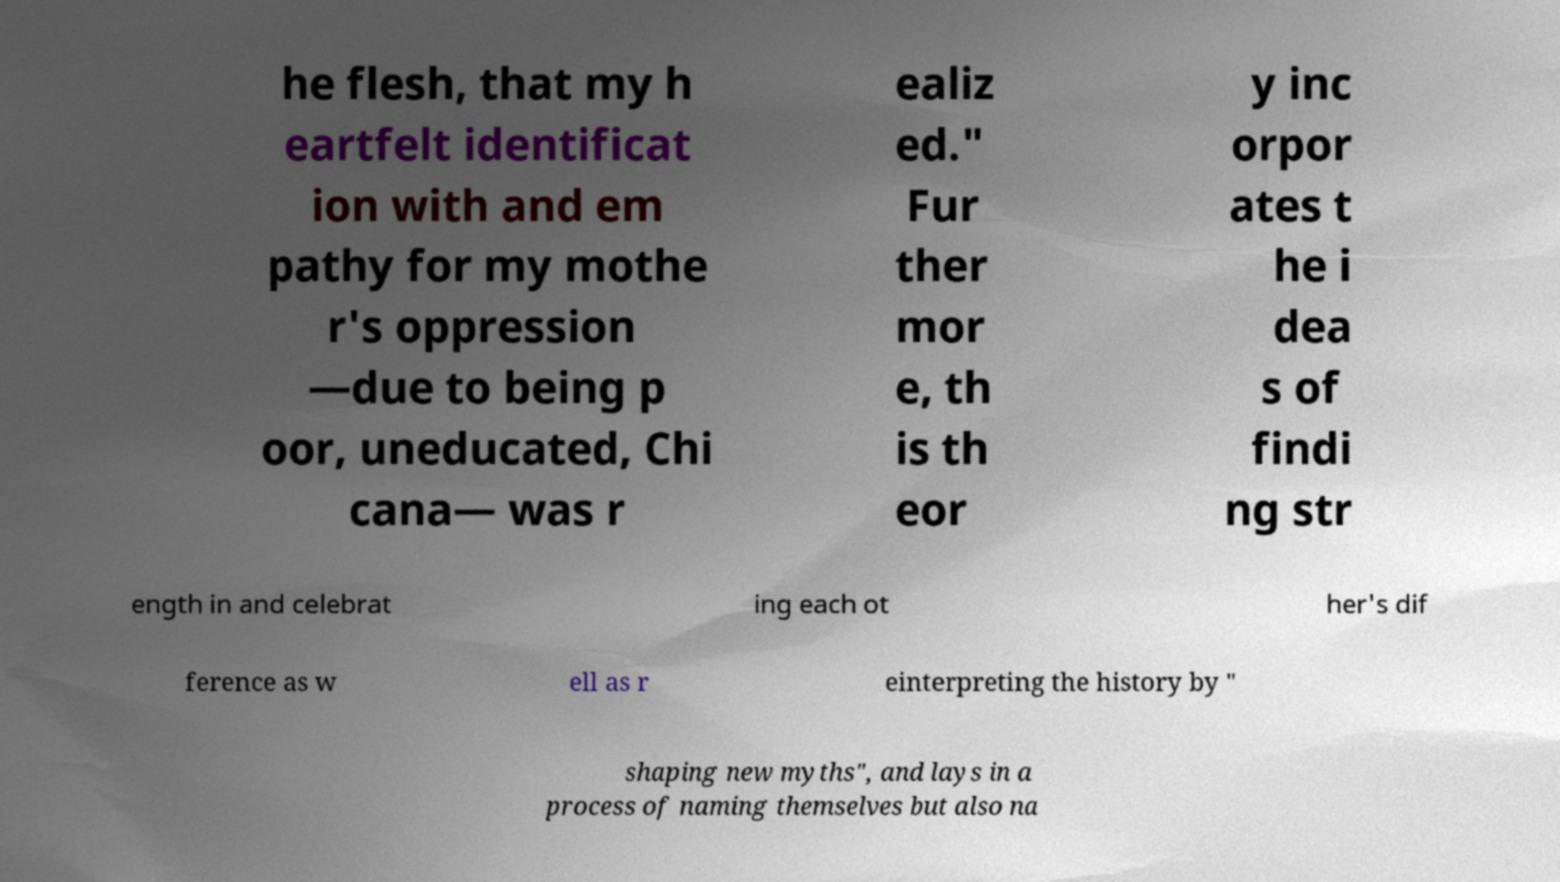Could you assist in decoding the text presented in this image and type it out clearly? he flesh, that my h eartfelt identificat ion with and em pathy for my mothe r's oppression —due to being p oor, uneducated, Chi cana— was r ealiz ed." Fur ther mor e, th is th eor y inc orpor ates t he i dea s of findi ng str ength in and celebrat ing each ot her's dif ference as w ell as r einterpreting the history by " shaping new myths", and lays in a process of naming themselves but also na 